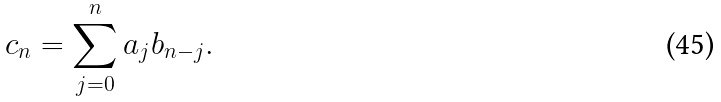Convert formula to latex. <formula><loc_0><loc_0><loc_500><loc_500>c _ { n } = \sum _ { j = 0 } ^ { n } a _ { j } b _ { n - j } .</formula> 